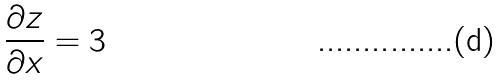<formula> <loc_0><loc_0><loc_500><loc_500>\frac { \partial z } { \partial x } = 3</formula> 